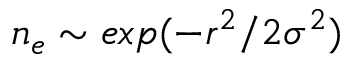Convert formula to latex. <formula><loc_0><loc_0><loc_500><loc_500>n _ { e } \sim e x p ( - r ^ { 2 } / 2 \sigma ^ { 2 } )</formula> 